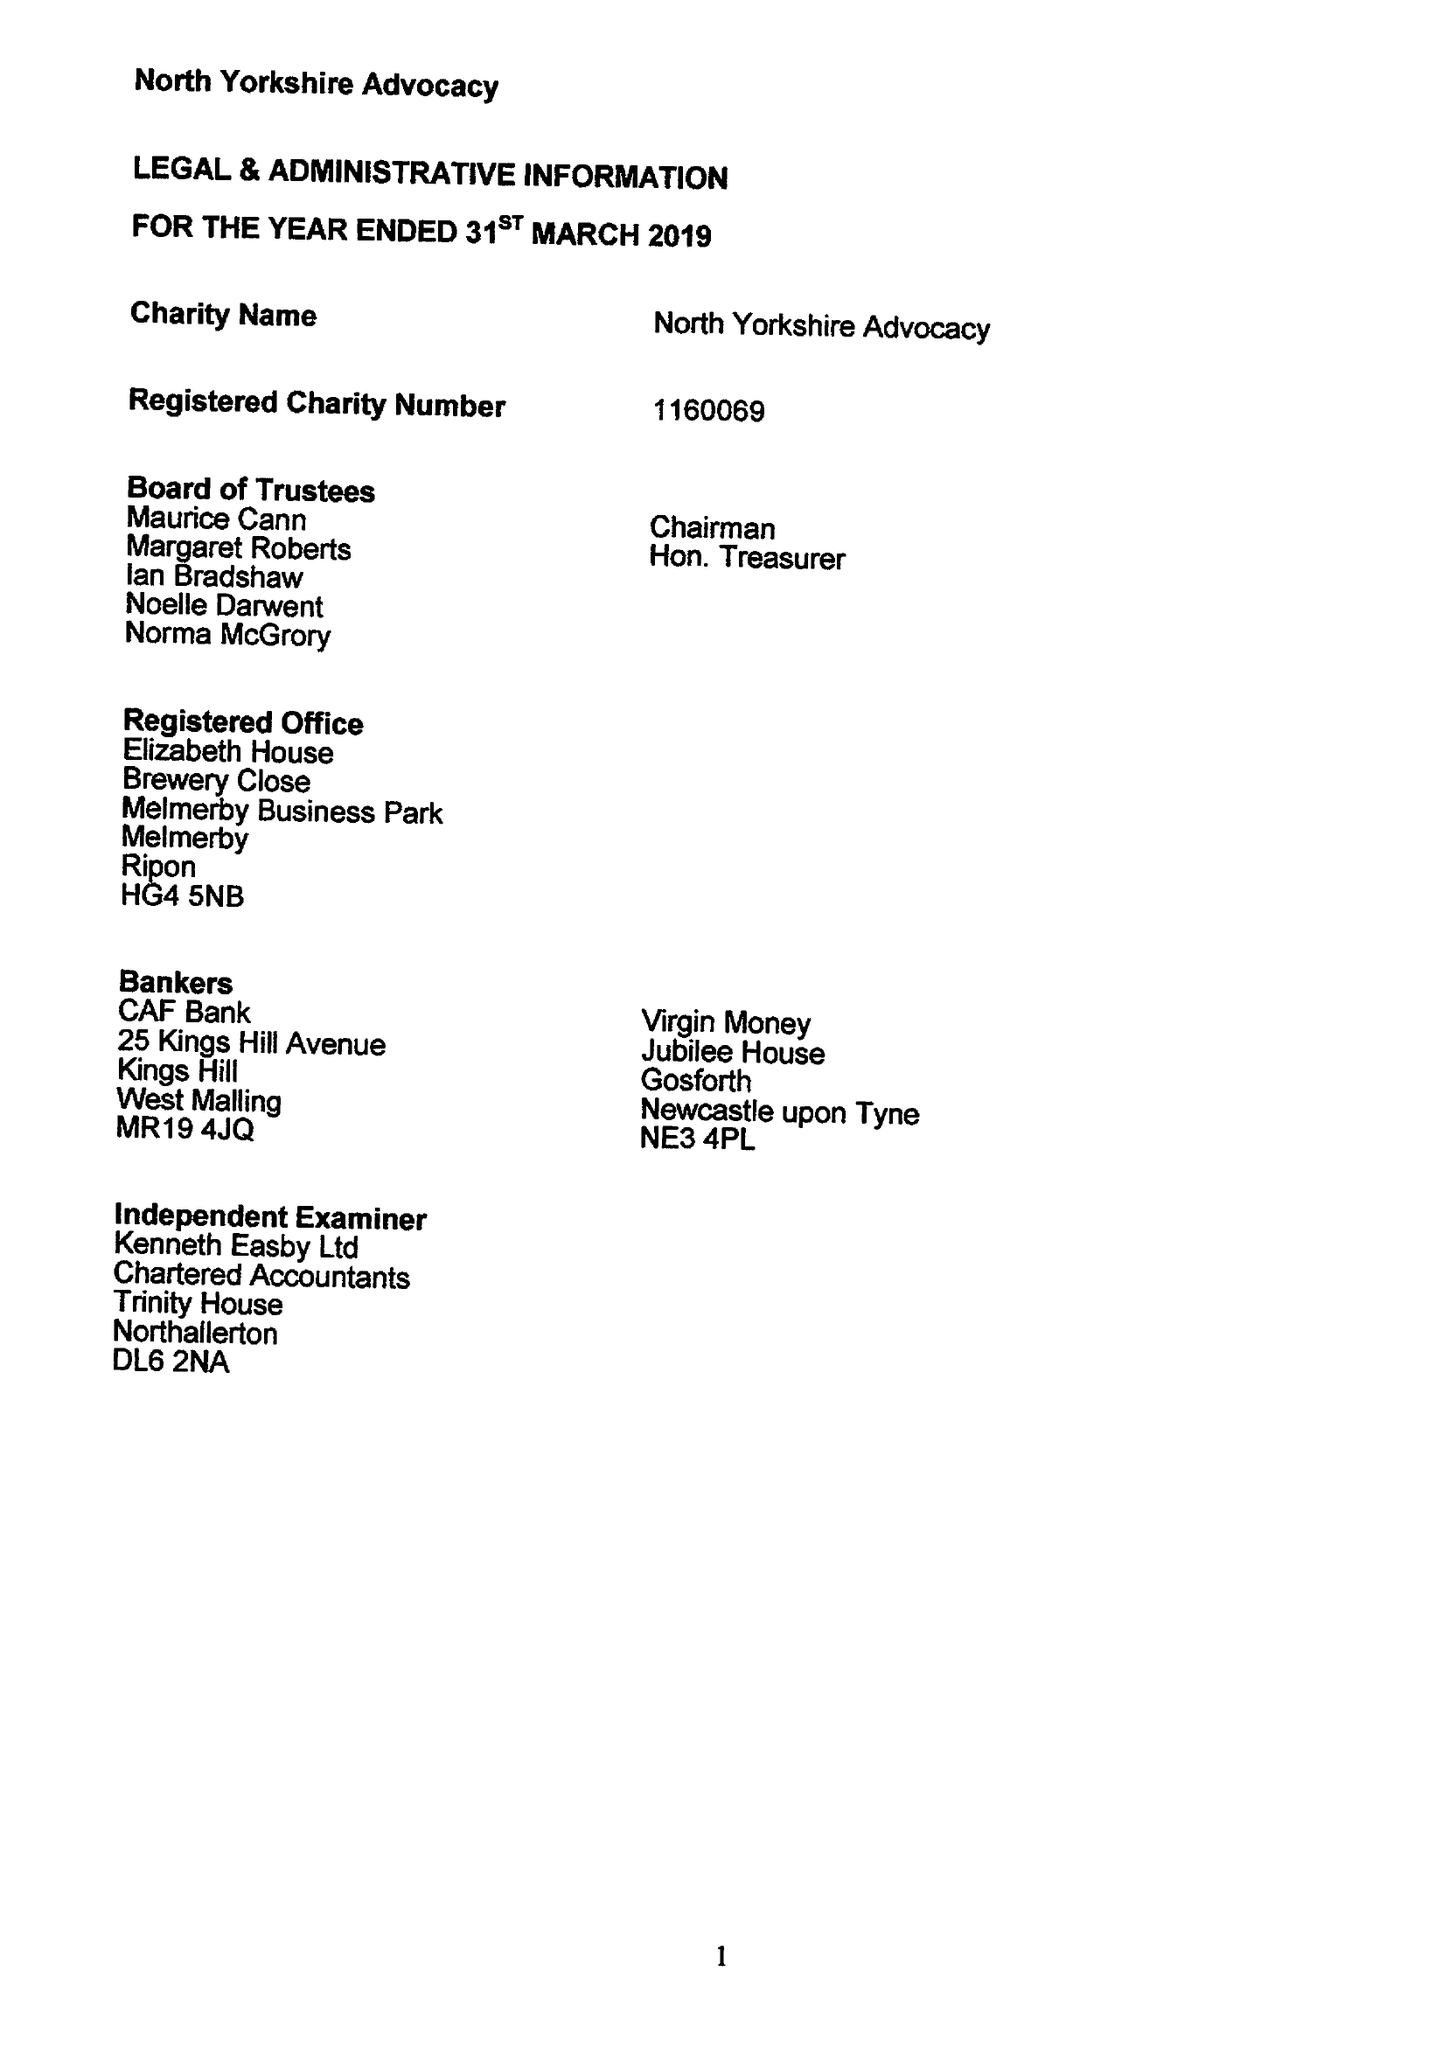What is the value for the address__post_town?
Answer the question using a single word or phrase. None 